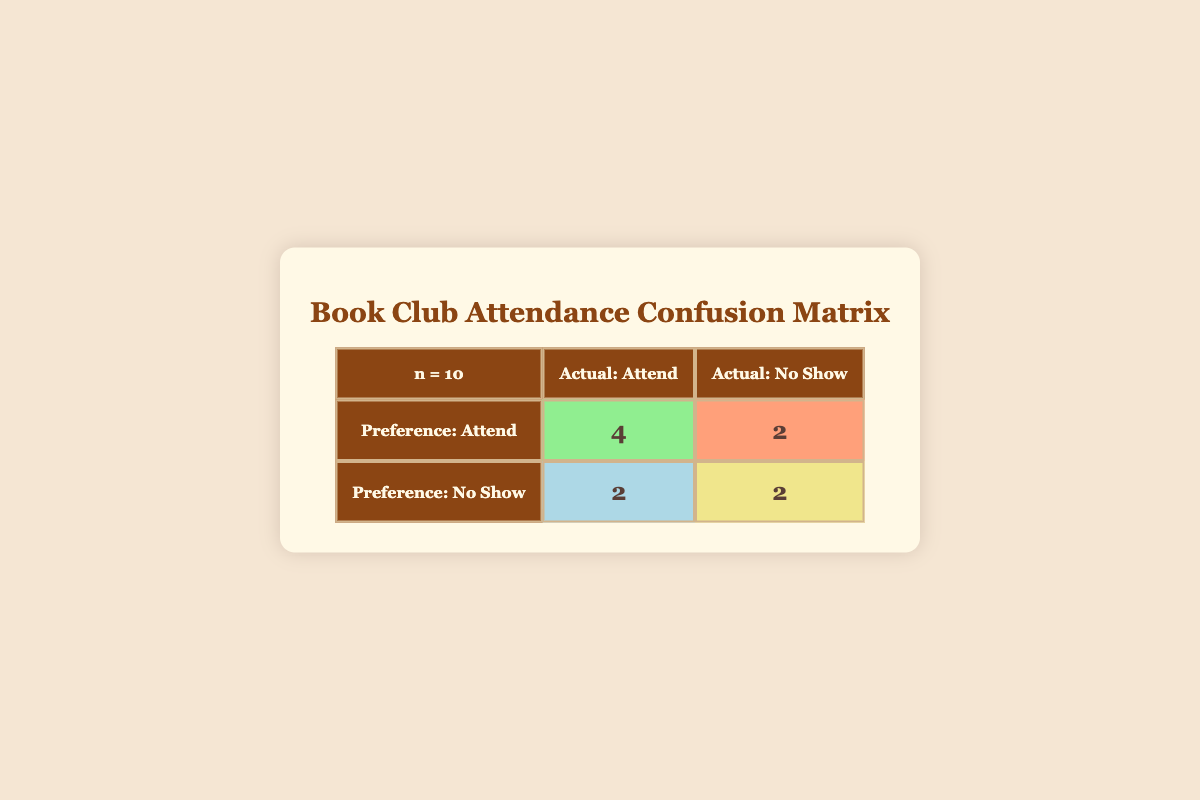What is the total number of guests who actually attended the book club meetings? From the table, we see that there are 3 true positives (guests who preferred to attend and actually attended) and 2 false negatives (guests who preferred not to attend but did attend). Summing these gives us 3 + 2 = 5 guests who actually attended the meetings.
Answer: 5 How many guests preferred to attend but did not show up? The table indicates that there are 2 false positives, which are guests who preferred to attend but actually did not show up. Therefore, the total number of guests who preferred to attend but didn't appear is 2.
Answer: 2 Is it true that more guests preferred to show up than to not show up? From the table, we see 5 guests preferred to attend (3 true positives + 2 false positives) and 5 guests preferred to not show up (2 false negatives + 3 true negatives). Since both are equal, the statement is false.
Answer: No What percentage of guests who preferred to attend successfully showed up? We can calculate the percentage by taking the number of true positives (3) and dividing it by the total number of guests who preferred to attend (5). So, (3/5) * 100 = 60%. Therefore, the percentage of those who preferred to attend and actually did is 60%.
Answer: 60% How many guests are there in total, and what is the average attendance rate based on their preferences? The total number of guests is 10. To calculate the attendance rate: total actual attendees = 5. The average attendance rate is thus (5/10) * 100 = 50%. Therefore, the average attendance rate based on their preferences is 50%.
Answer: 50% What is the difference between the number of true positives and false negatives? There are 3 true positives and 2 false negatives. The difference is 3 - 2 = 1. Hence, the difference between the true positives and false negatives is 1.
Answer: 1 